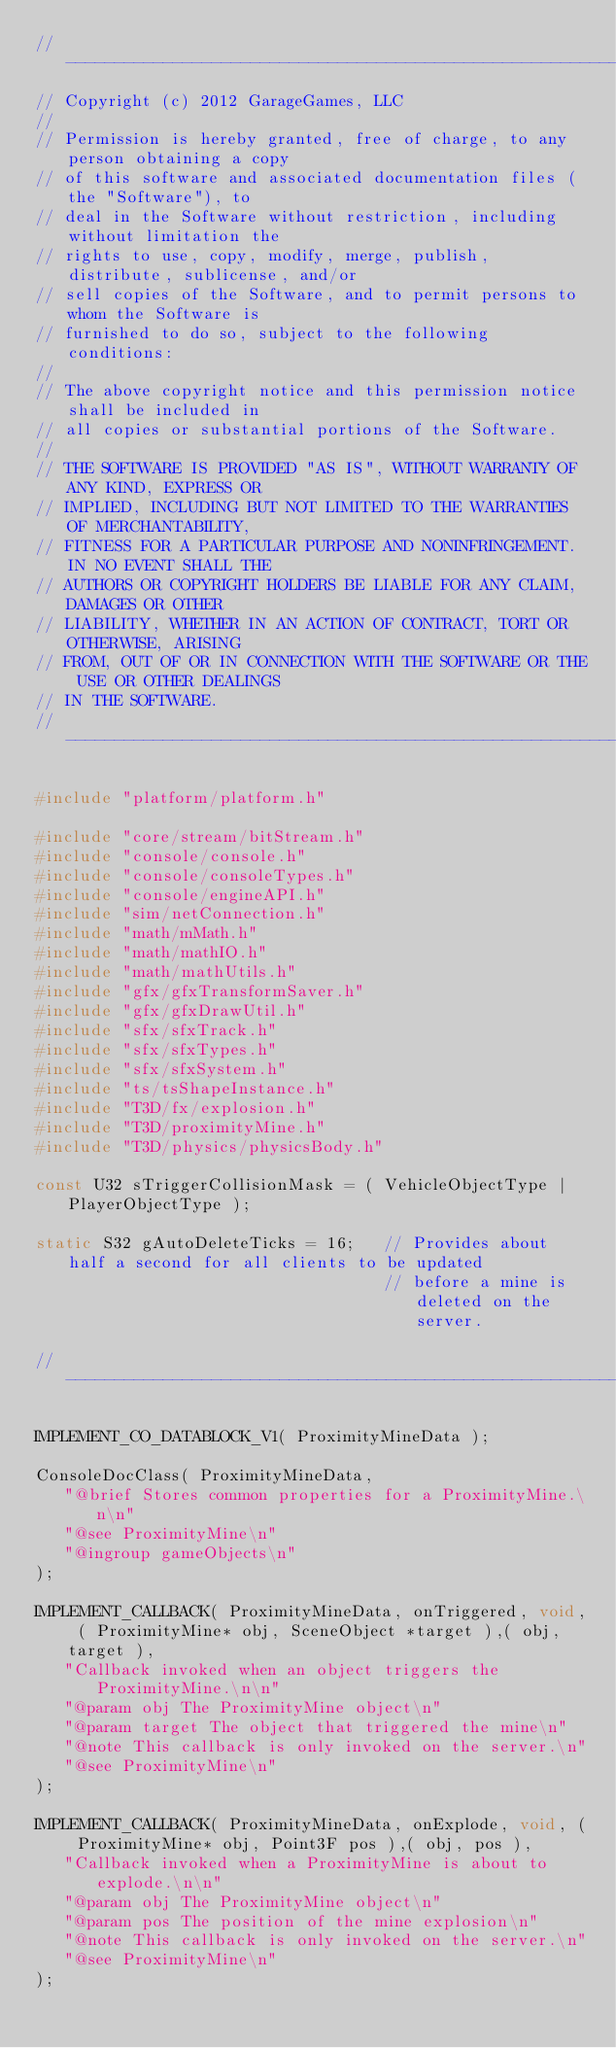Convert code to text. <code><loc_0><loc_0><loc_500><loc_500><_C++_>//-----------------------------------------------------------------------------
// Copyright (c) 2012 GarageGames, LLC
//
// Permission is hereby granted, free of charge, to any person obtaining a copy
// of this software and associated documentation files (the "Software"), to
// deal in the Software without restriction, including without limitation the
// rights to use, copy, modify, merge, publish, distribute, sublicense, and/or
// sell copies of the Software, and to permit persons to whom the Software is
// furnished to do so, subject to the following conditions:
//
// The above copyright notice and this permission notice shall be included in
// all copies or substantial portions of the Software.
//
// THE SOFTWARE IS PROVIDED "AS IS", WITHOUT WARRANTY OF ANY KIND, EXPRESS OR
// IMPLIED, INCLUDING BUT NOT LIMITED TO THE WARRANTIES OF MERCHANTABILITY,
// FITNESS FOR A PARTICULAR PURPOSE AND NONINFRINGEMENT. IN NO EVENT SHALL THE
// AUTHORS OR COPYRIGHT HOLDERS BE LIABLE FOR ANY CLAIM, DAMAGES OR OTHER
// LIABILITY, WHETHER IN AN ACTION OF CONTRACT, TORT OR OTHERWISE, ARISING
// FROM, OUT OF OR IN CONNECTION WITH THE SOFTWARE OR THE USE OR OTHER DEALINGS
// IN THE SOFTWARE.
//-----------------------------------------------------------------------------

#include "platform/platform.h"

#include "core/stream/bitStream.h"
#include "console/console.h"
#include "console/consoleTypes.h"
#include "console/engineAPI.h"
#include "sim/netConnection.h"
#include "math/mMath.h"
#include "math/mathIO.h"
#include "math/mathUtils.h"
#include "gfx/gfxTransformSaver.h"
#include "gfx/gfxDrawUtil.h"
#include "sfx/sfxTrack.h"
#include "sfx/sfxTypes.h"
#include "sfx/sfxSystem.h"
#include "ts/tsShapeInstance.h"
#include "T3D/fx/explosion.h"
#include "T3D/proximityMine.h"
#include "T3D/physics/physicsBody.h"

const U32 sTriggerCollisionMask = ( VehicleObjectType | PlayerObjectType );

static S32 gAutoDeleteTicks = 16;   // Provides about half a second for all clients to be updated
                                    // before a mine is deleted on the server.

//----------------------------------------------------------------------------

IMPLEMENT_CO_DATABLOCK_V1( ProximityMineData );

ConsoleDocClass( ProximityMineData,
   "@brief Stores common properties for a ProximityMine.\n\n"
   "@see ProximityMine\n"
   "@ingroup gameObjects\n"
);

IMPLEMENT_CALLBACK( ProximityMineData, onTriggered, void, ( ProximityMine* obj, SceneObject *target ),( obj, target ),
   "Callback invoked when an object triggers the ProximityMine.\n\n"
   "@param obj The ProximityMine object\n"
   "@param target The object that triggered the mine\n"
   "@note This callback is only invoked on the server.\n"
   "@see ProximityMine\n"
);

IMPLEMENT_CALLBACK( ProximityMineData, onExplode, void, ( ProximityMine* obj, Point3F pos ),( obj, pos ),
   "Callback invoked when a ProximityMine is about to explode.\n\n"
   "@param obj The ProximityMine object\n"
   "@param pos The position of the mine explosion\n"
   "@note This callback is only invoked on the server.\n"
   "@see ProximityMine\n"
);
</code> 